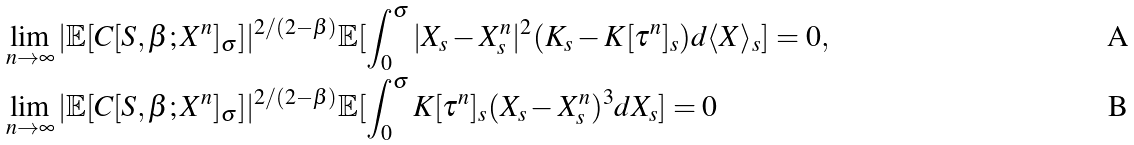<formula> <loc_0><loc_0><loc_500><loc_500>& \lim _ { n \to \infty } | \mathbb { E } [ C [ S , \beta ; X ^ { n } ] _ { \sigma } ] | ^ { 2 / ( 2 - \beta ) } \mathbb { E } [ \int _ { 0 } ^ { \sigma } | X _ { s } - X ^ { n } _ { s } | ^ { 2 } ( K _ { s } - K [ \tau ^ { n } ] _ { s } ) d \langle X \rangle _ { s } ] = 0 , \\ & \lim _ { n \to \infty } | \mathbb { E } [ C [ S , \beta ; X ^ { n } ] _ { \sigma } ] | ^ { 2 / ( 2 - \beta ) } \mathbb { E } [ \int _ { 0 } ^ { \sigma } K [ \tau ^ { n } ] _ { s } ( X _ { s } - X ^ { n } _ { s } ) ^ { 3 } d X _ { s } ] = 0</formula> 